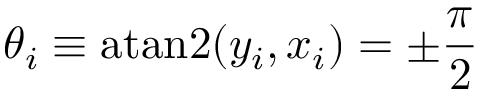Convert formula to latex. <formula><loc_0><loc_0><loc_500><loc_500>\theta _ { i } \equiv a t a n 2 ( y _ { i } , x _ { i } ) = \pm \frac { \pi } { 2 }</formula> 